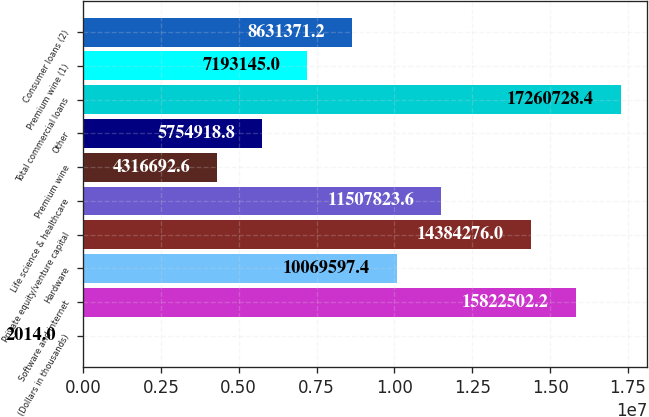Convert chart to OTSL. <chart><loc_0><loc_0><loc_500><loc_500><bar_chart><fcel>(Dollars in thousands)<fcel>Software and internet<fcel>Hardware<fcel>Private equity/venture capital<fcel>Life science & healthcare<fcel>Premium wine<fcel>Other<fcel>Total commercial loans<fcel>Premium wine (1)<fcel>Consumer loans (2)<nl><fcel>2014<fcel>1.58225e+07<fcel>1.00696e+07<fcel>1.43843e+07<fcel>1.15078e+07<fcel>4.31669e+06<fcel>5.75492e+06<fcel>1.72607e+07<fcel>7.19314e+06<fcel>8.63137e+06<nl></chart> 